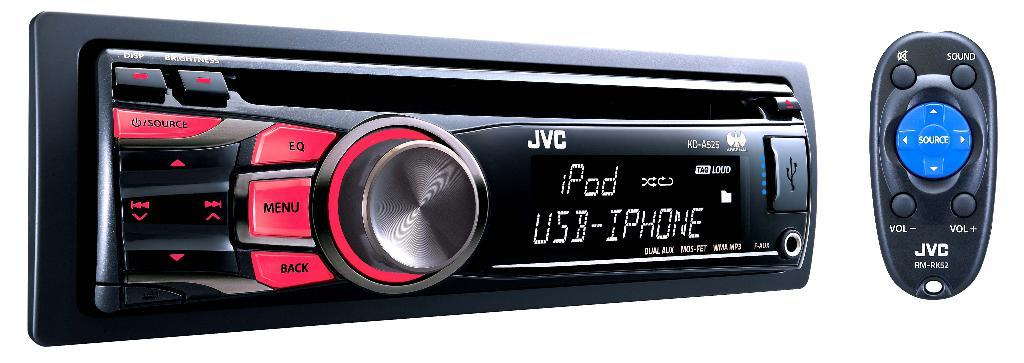What is the main object in the image? There is a car stereo in the image. What features does the car stereo have? The car stereo has buttons. What other object is visible in the image? There is a remote in the image. What type of vase is placed on the car stereo in the image? There is no vase present on the car stereo in the image. What teeth-related activity is happening in the image? There is no teeth-related activity depicted in the image. 